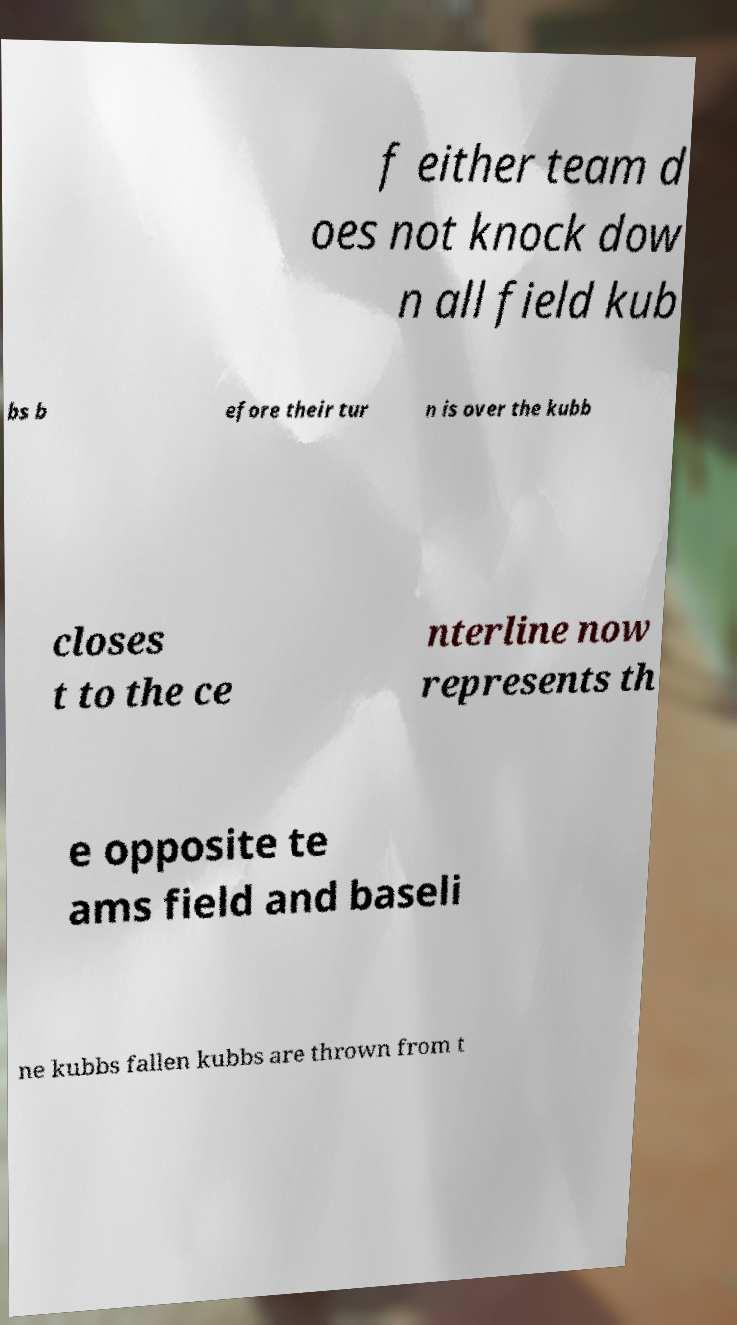Could you assist in decoding the text presented in this image and type it out clearly? f either team d oes not knock dow n all field kub bs b efore their tur n is over the kubb closes t to the ce nterline now represents th e opposite te ams field and baseli ne kubbs fallen kubbs are thrown from t 